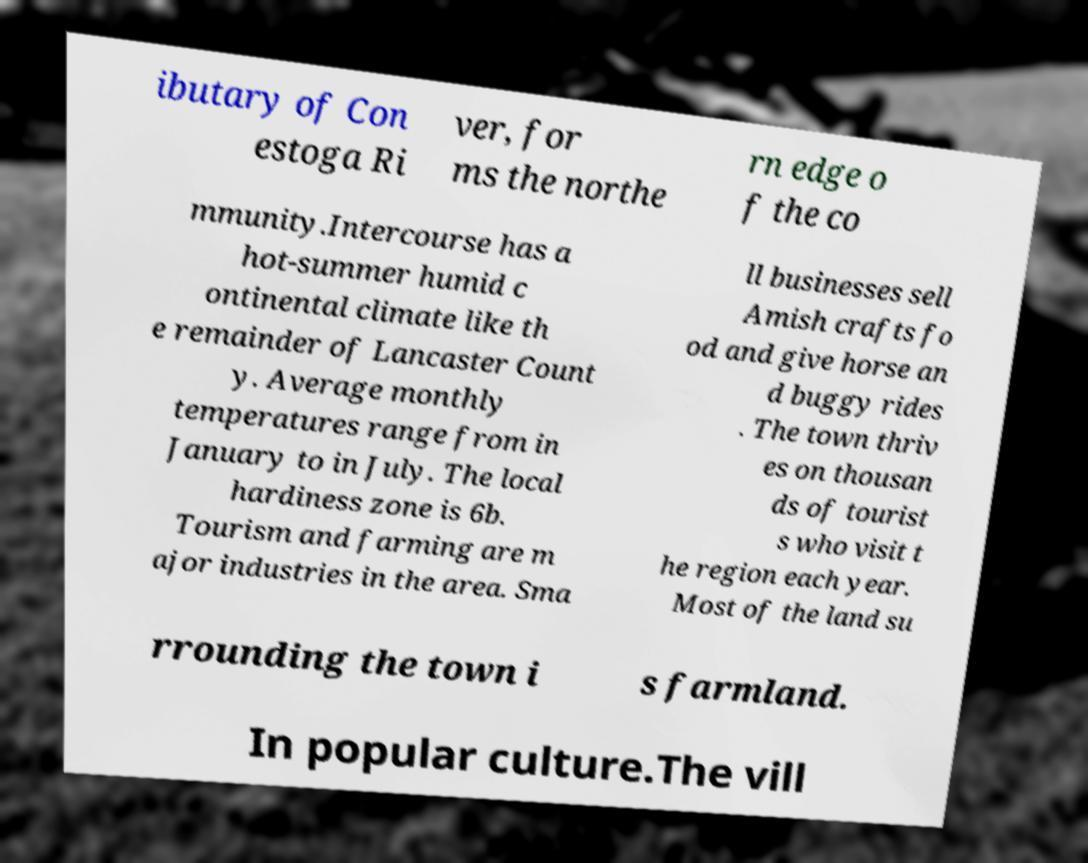There's text embedded in this image that I need extracted. Can you transcribe it verbatim? ibutary of Con estoga Ri ver, for ms the northe rn edge o f the co mmunity.Intercourse has a hot-summer humid c ontinental climate like th e remainder of Lancaster Count y. Average monthly temperatures range from in January to in July. The local hardiness zone is 6b. Tourism and farming are m ajor industries in the area. Sma ll businesses sell Amish crafts fo od and give horse an d buggy rides . The town thriv es on thousan ds of tourist s who visit t he region each year. Most of the land su rrounding the town i s farmland. In popular culture.The vill 